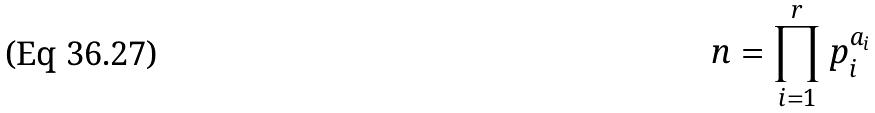<formula> <loc_0><loc_0><loc_500><loc_500>n = \prod _ { i = 1 } ^ { r } p _ { i } ^ { a _ { i } }</formula> 